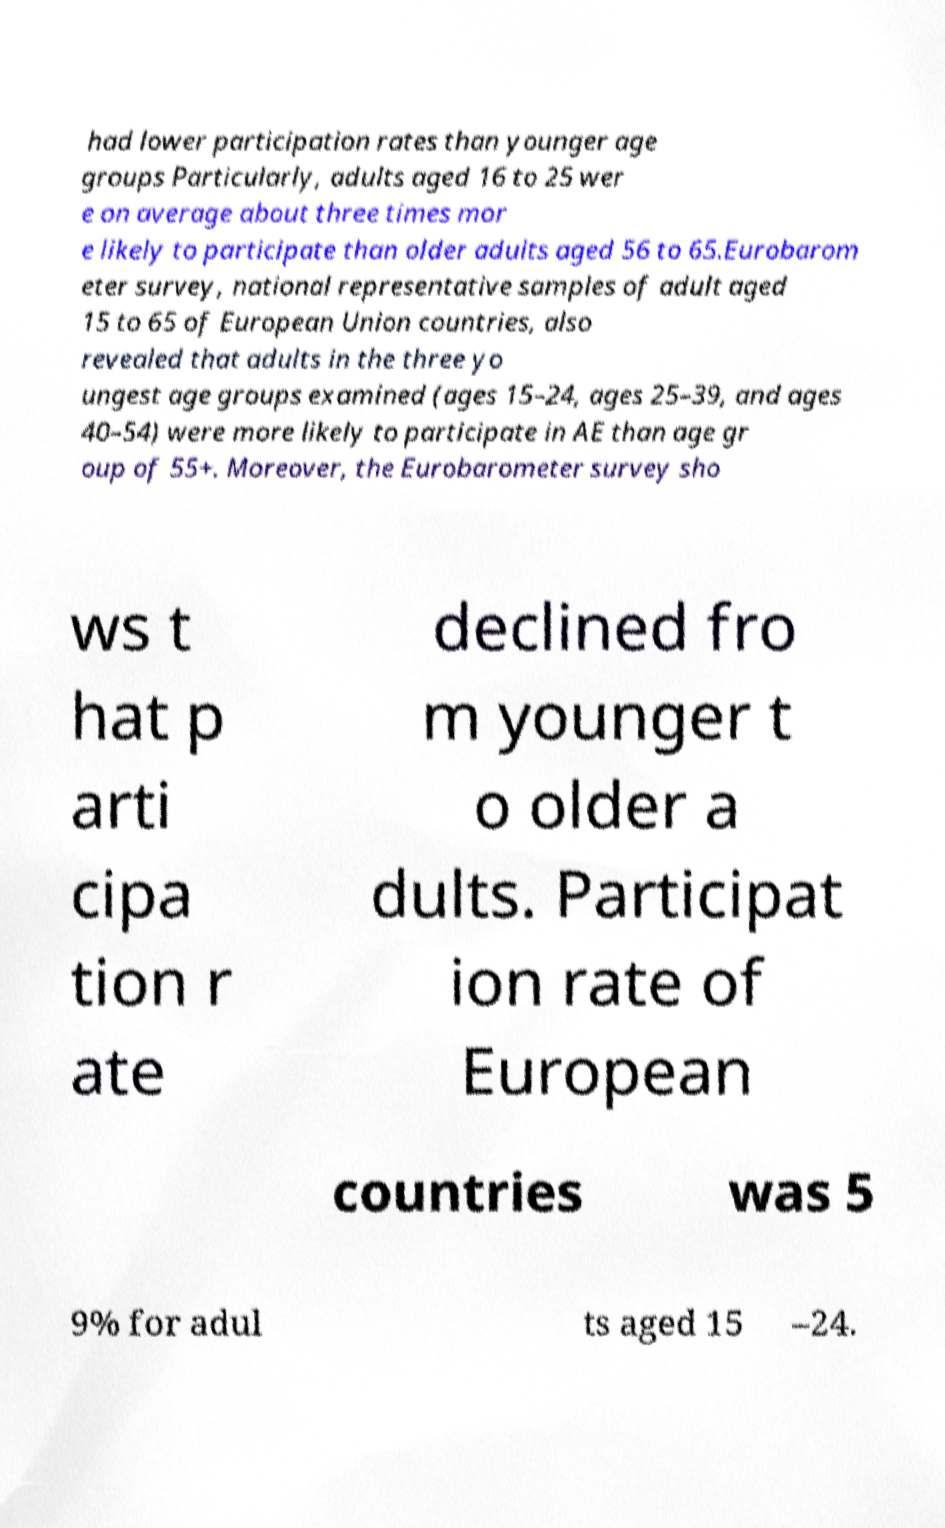I need the written content from this picture converted into text. Can you do that? had lower participation rates than younger age groups Particularly, adults aged 16 to 25 wer e on average about three times mor e likely to participate than older adults aged 56 to 65.Eurobarom eter survey, national representative samples of adult aged 15 to 65 of European Union countries, also revealed that adults in the three yo ungest age groups examined (ages 15–24, ages 25–39, and ages 40–54) were more likely to participate in AE than age gr oup of 55+. Moreover, the Eurobarometer survey sho ws t hat p arti cipa tion r ate declined fro m younger t o older a dults. Participat ion rate of European countries was 5 9% for adul ts aged 15 –24. 